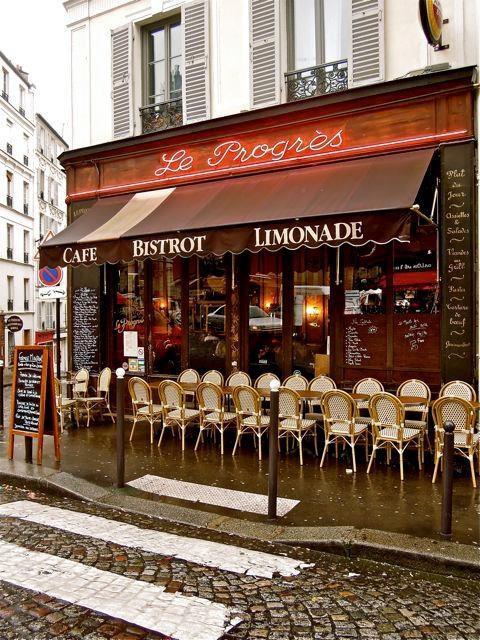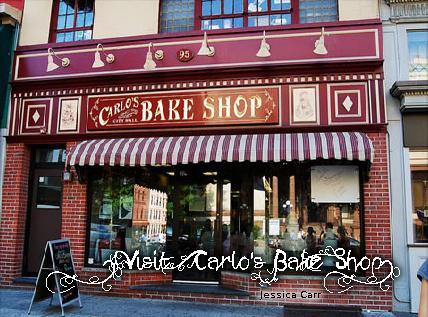The first image is the image on the left, the second image is the image on the right. For the images displayed, is the sentence "In at least one image there is a shelve of bake goods inside a bakery." factually correct? Answer yes or no. No. The first image is the image on the left, the second image is the image on the right. Analyze the images presented: Is the assertion "One of the shops has tables and chairs out front." valid? Answer yes or no. Yes. 